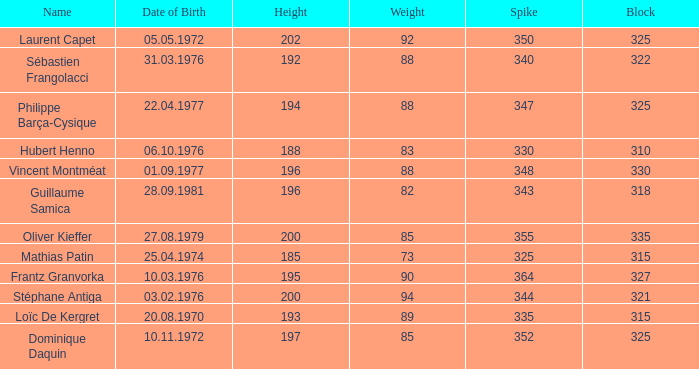How many spikes have 28.09.1981 as the date of birth, with a block greater than 318? None. 